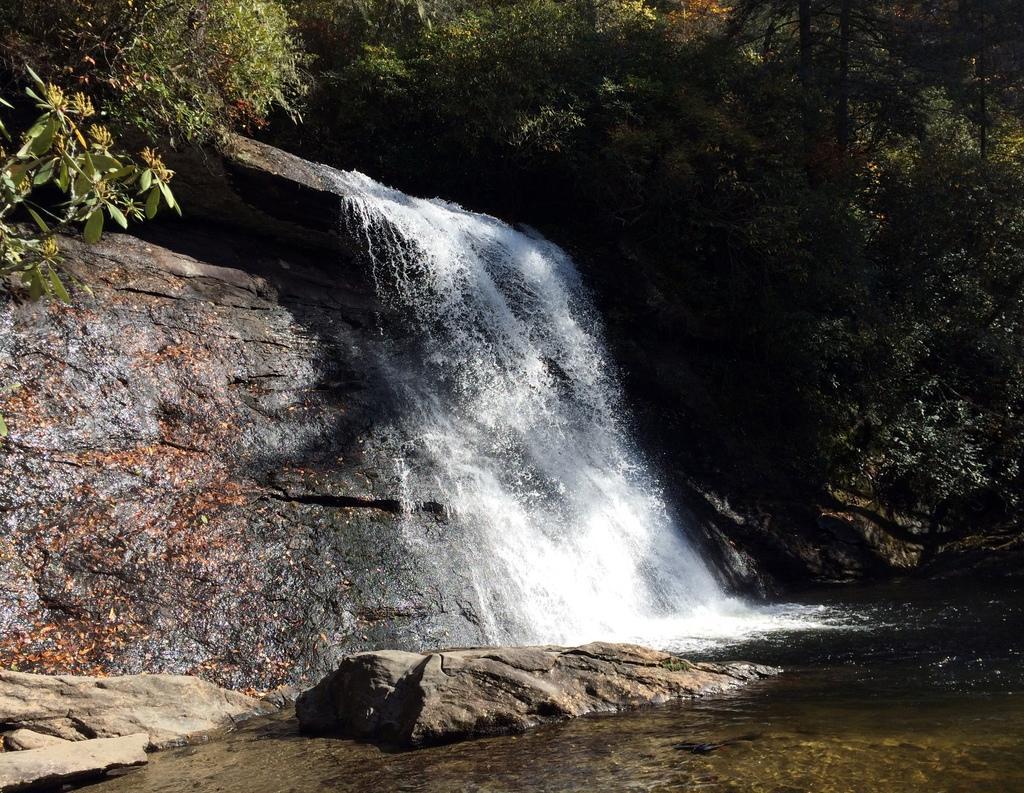Can you describe this image briefly? This image consists of trees, waterfall, rocks and a mountain. This image is taken may be during a day. 